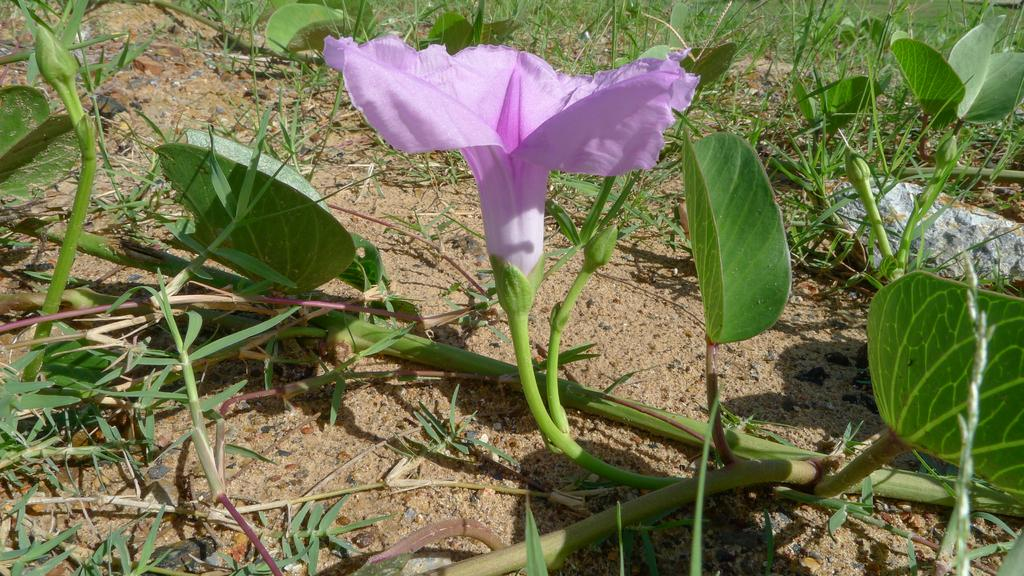What type of plants can be seen in the image? There are flower plants in the image. Can you describe the appearance of the flower plants? The flower plants have colorful blooms and green leaves. Are there any other objects or elements in the image besides the flower plants? The provided facts do not mention any other objects or elements in the image. What type of feast is being prepared in the image? There is no feast or preparation for a feast visible in the image; it only features flower plants. 